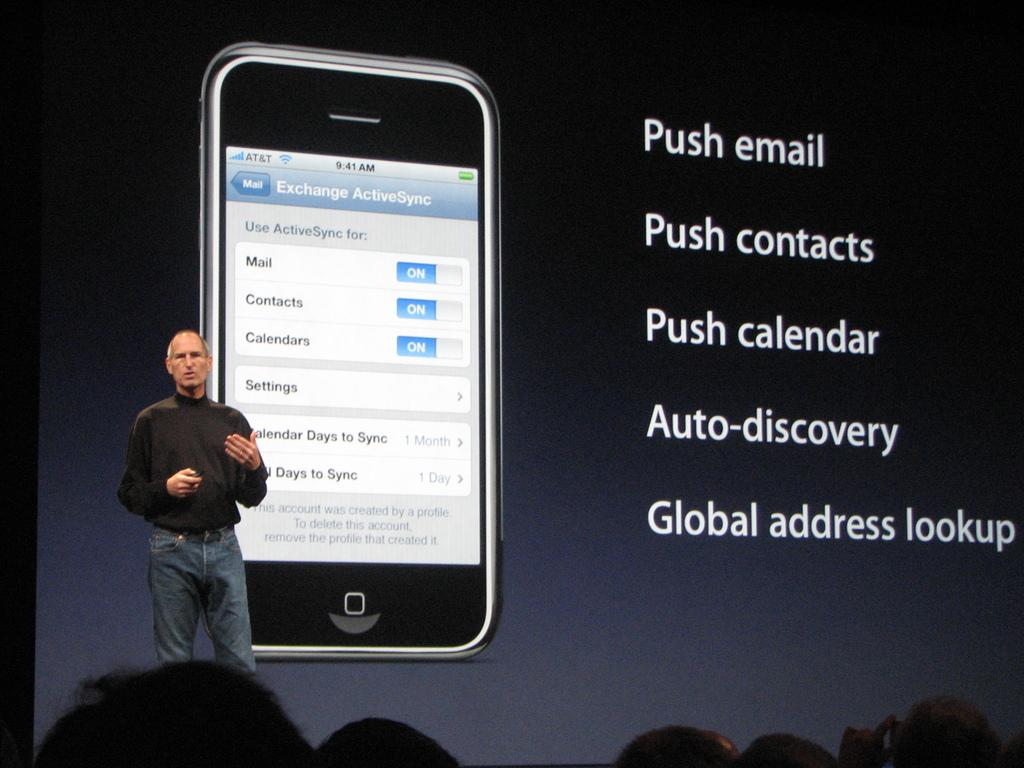<image>
Create a compact narrative representing the image presented. Person giving a presentation showing a phone and "Push email" on top. 